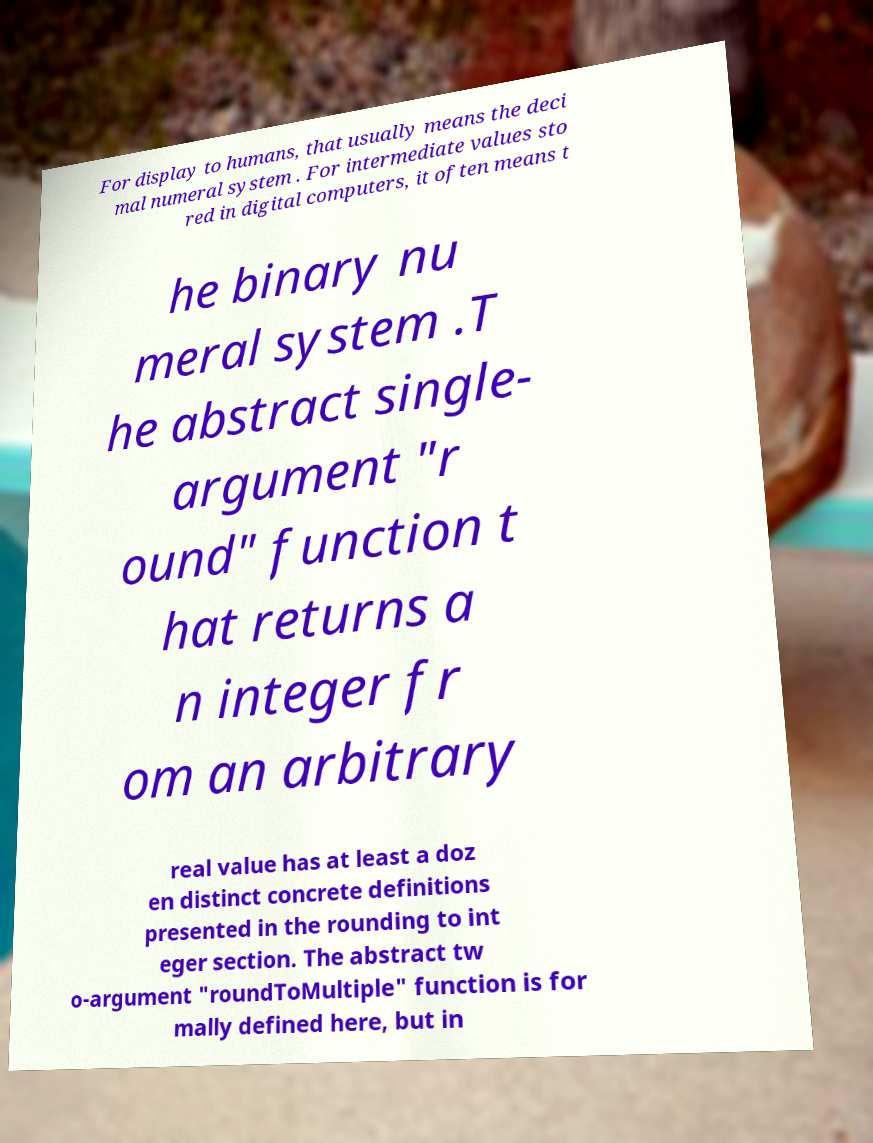Please identify and transcribe the text found in this image. For display to humans, that usually means the deci mal numeral system . For intermediate values sto red in digital computers, it often means t he binary nu meral system .T he abstract single- argument "r ound" function t hat returns a n integer fr om an arbitrary real value has at least a doz en distinct concrete definitions presented in the rounding to int eger section. The abstract tw o-argument "roundToMultiple" function is for mally defined here, but in 